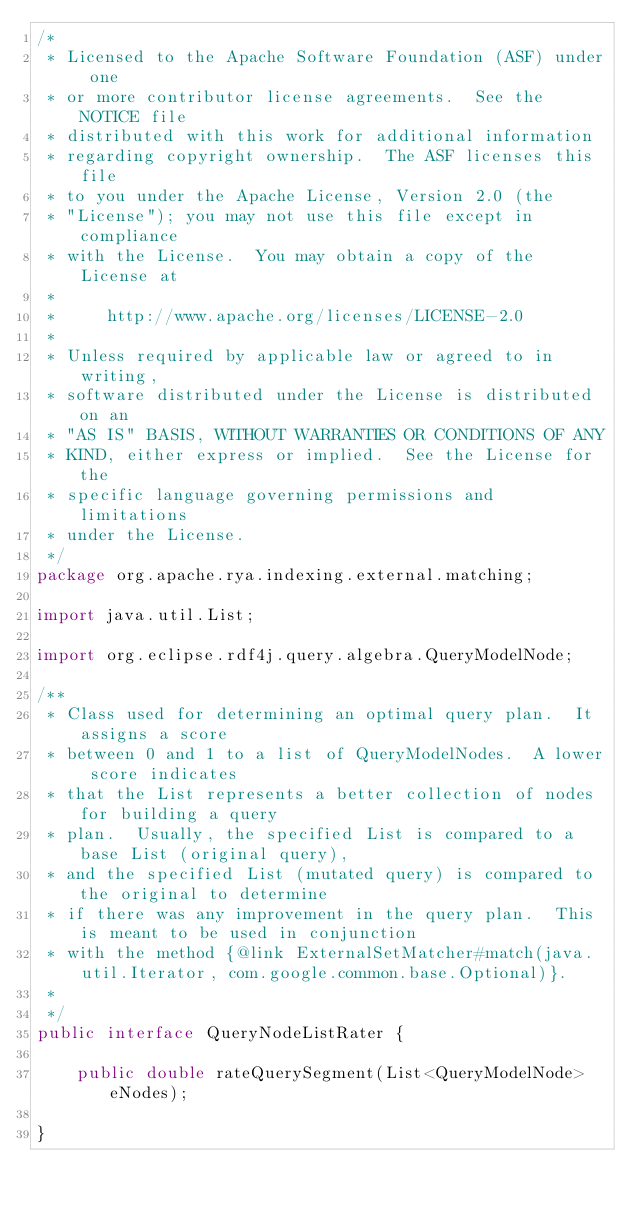<code> <loc_0><loc_0><loc_500><loc_500><_Java_>/*
 * Licensed to the Apache Software Foundation (ASF) under one
 * or more contributor license agreements.  See the NOTICE file
 * distributed with this work for additional information
 * regarding copyright ownership.  The ASF licenses this file
 * to you under the Apache License, Version 2.0 (the
 * "License"); you may not use this file except in compliance
 * with the License.  You may obtain a copy of the License at
 *
 *     http://www.apache.org/licenses/LICENSE-2.0
 *
 * Unless required by applicable law or agreed to in writing,
 * software distributed under the License is distributed on an
 * "AS IS" BASIS, WITHOUT WARRANTIES OR CONDITIONS OF ANY
 * KIND, either express or implied.  See the License for the
 * specific language governing permissions and limitations
 * under the License.
 */
package org.apache.rya.indexing.external.matching;

import java.util.List;

import org.eclipse.rdf4j.query.algebra.QueryModelNode;

/**
 * Class used for determining an optimal query plan.  It assigns a score
 * between 0 and 1 to a list of QueryModelNodes.  A lower score indicates
 * that the List represents a better collection of nodes for building a query
 * plan.  Usually, the specified List is compared to a base List (original query),
 * and the specified List (mutated query) is compared to the original to determine
 * if there was any improvement in the query plan.  This is meant to be used in conjunction
 * with the method {@link ExternalSetMatcher#match(java.util.Iterator, com.google.common.base.Optional)}.
 *
 */
public interface QueryNodeListRater {

    public double rateQuerySegment(List<QueryModelNode> eNodes);

}
</code> 